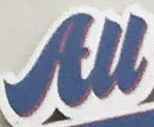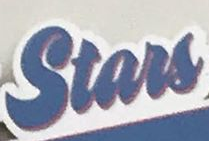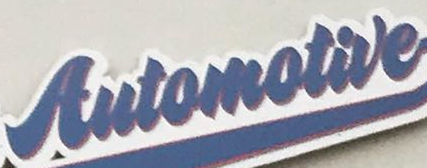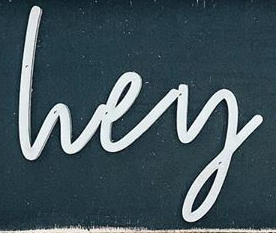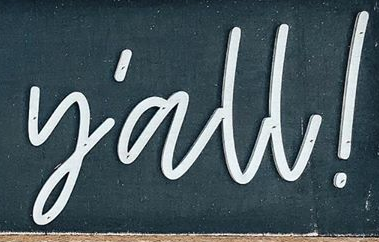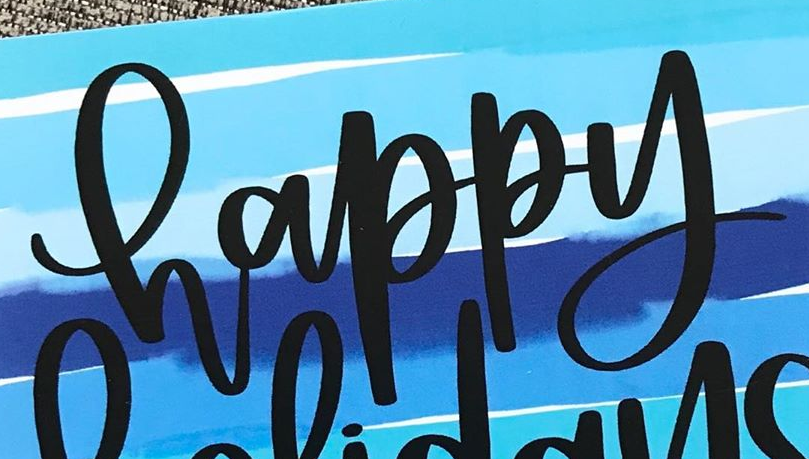What text appears in these images from left to right, separated by a semicolon? All; Stars; Automotive; lvey; y'all!; happy 